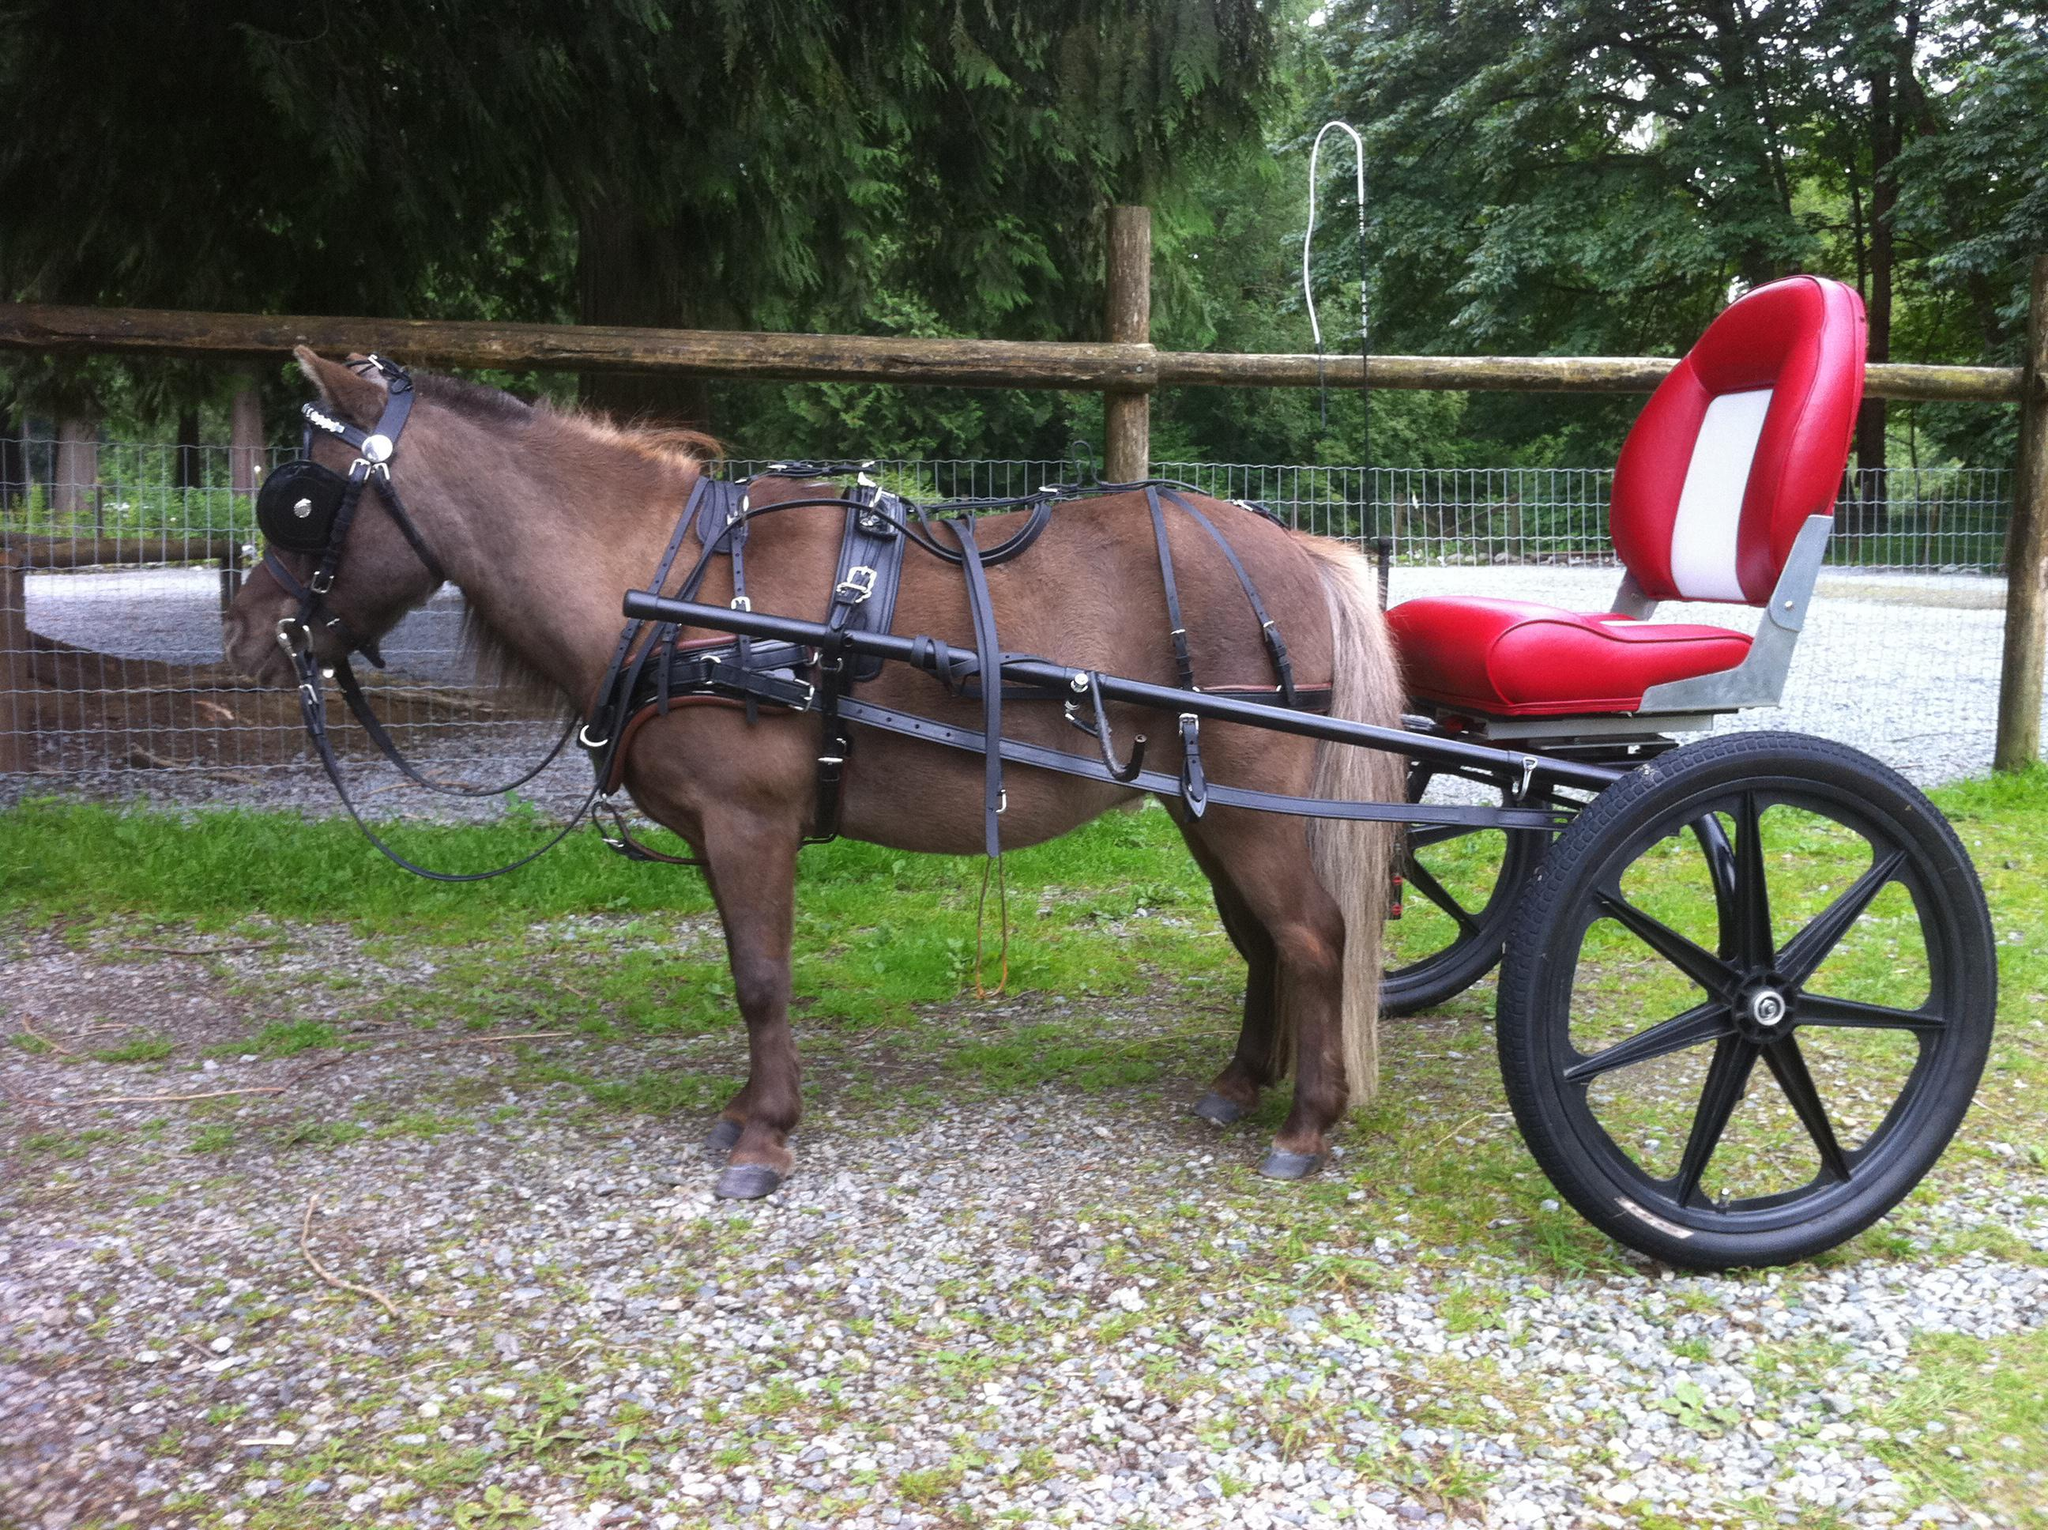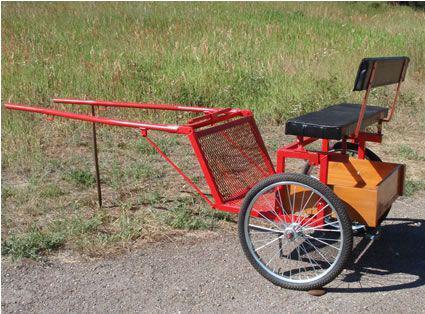The first image is the image on the left, the second image is the image on the right. Considering the images on both sides, is "There is exactly one horse in the iamge on the left." valid? Answer yes or no. Yes. 